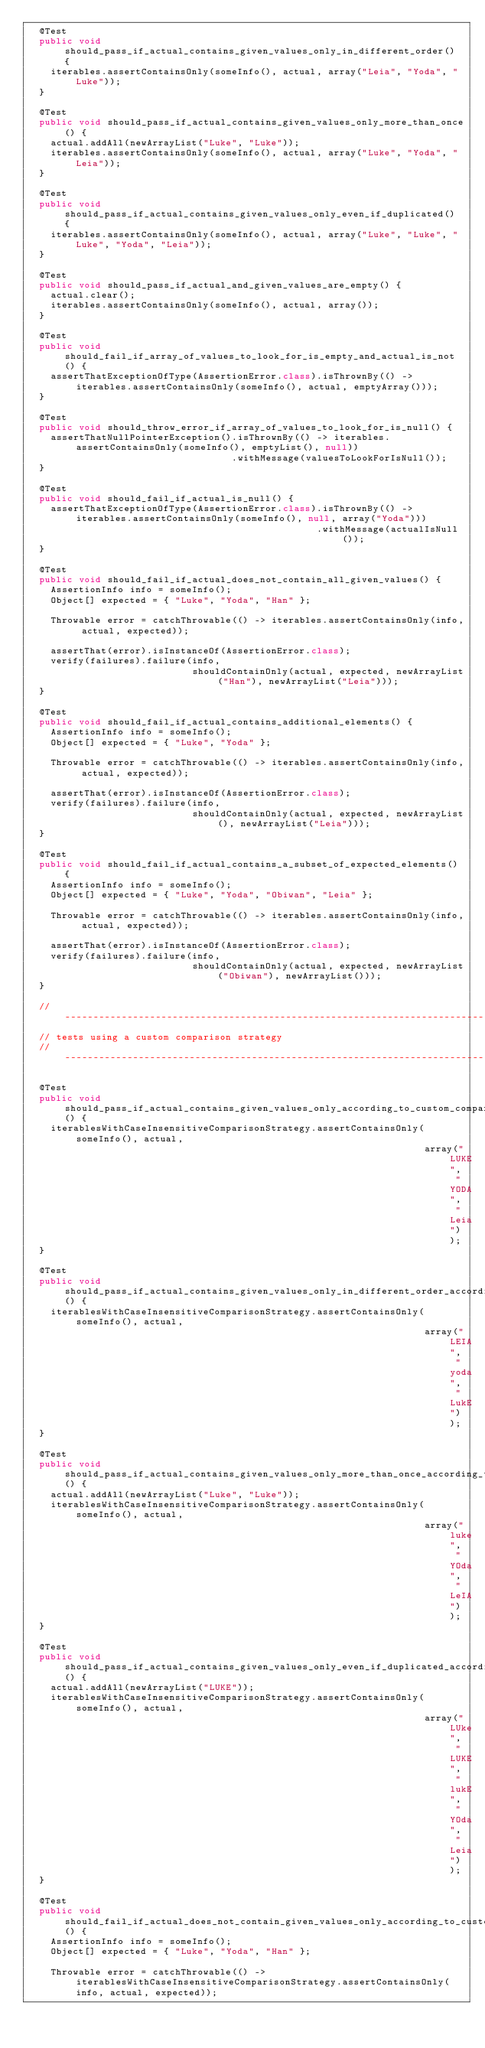<code> <loc_0><loc_0><loc_500><loc_500><_Java_>  @Test
  public void should_pass_if_actual_contains_given_values_only_in_different_order() {
    iterables.assertContainsOnly(someInfo(), actual, array("Leia", "Yoda", "Luke"));
  }

  @Test
  public void should_pass_if_actual_contains_given_values_only_more_than_once() {
    actual.addAll(newArrayList("Luke", "Luke"));
    iterables.assertContainsOnly(someInfo(), actual, array("Luke", "Yoda", "Leia"));
  }

  @Test
  public void should_pass_if_actual_contains_given_values_only_even_if_duplicated() {
    iterables.assertContainsOnly(someInfo(), actual, array("Luke", "Luke", "Luke", "Yoda", "Leia"));
  }

  @Test
  public void should_pass_if_actual_and_given_values_are_empty() {
    actual.clear();
    iterables.assertContainsOnly(someInfo(), actual, array());
  }

  @Test
  public void should_fail_if_array_of_values_to_look_for_is_empty_and_actual_is_not() {
    assertThatExceptionOfType(AssertionError.class).isThrownBy(() -> iterables.assertContainsOnly(someInfo(), actual, emptyArray()));
  }

  @Test
  public void should_throw_error_if_array_of_values_to_look_for_is_null() {
    assertThatNullPointerException().isThrownBy(() -> iterables.assertContainsOnly(someInfo(), emptyList(), null))
                                    .withMessage(valuesToLookForIsNull());
  }

  @Test
  public void should_fail_if_actual_is_null() {
    assertThatExceptionOfType(AssertionError.class).isThrownBy(() -> iterables.assertContainsOnly(someInfo(), null, array("Yoda")))
                                                   .withMessage(actualIsNull());
  }

  @Test
  public void should_fail_if_actual_does_not_contain_all_given_values() {
    AssertionInfo info = someInfo();
    Object[] expected = { "Luke", "Yoda", "Han" };

    Throwable error = catchThrowable(() -> iterables.assertContainsOnly(info, actual, expected));

    assertThat(error).isInstanceOf(AssertionError.class);
    verify(failures).failure(info,
                             shouldContainOnly(actual, expected, newArrayList("Han"), newArrayList("Leia")));
  }

  @Test
  public void should_fail_if_actual_contains_additional_elements() {
    AssertionInfo info = someInfo();
    Object[] expected = { "Luke", "Yoda" };

    Throwable error = catchThrowable(() -> iterables.assertContainsOnly(info, actual, expected));

    assertThat(error).isInstanceOf(AssertionError.class);
    verify(failures).failure(info,
                             shouldContainOnly(actual, expected, newArrayList(), newArrayList("Leia")));
  }

  @Test
  public void should_fail_if_actual_contains_a_subset_of_expected_elements() {
    AssertionInfo info = someInfo();
    Object[] expected = { "Luke", "Yoda", "Obiwan", "Leia" };

    Throwable error = catchThrowable(() -> iterables.assertContainsOnly(info, actual, expected));

    assertThat(error).isInstanceOf(AssertionError.class);
    verify(failures).failure(info,
                             shouldContainOnly(actual, expected, newArrayList("Obiwan"), newArrayList()));
  }

  // ------------------------------------------------------------------------------------------------------------------
  // tests using a custom comparison strategy
  // ------------------------------------------------------------------------------------------------------------------

  @Test
  public void should_pass_if_actual_contains_given_values_only_according_to_custom_comparison_strategy() {
    iterablesWithCaseInsensitiveComparisonStrategy.assertContainsOnly(someInfo(), actual,
                                                                      array("LUKE", "YODA", "Leia"));
  }

  @Test
  public void should_pass_if_actual_contains_given_values_only_in_different_order_according_to_custom_comparison_strategy() {
    iterablesWithCaseInsensitiveComparisonStrategy.assertContainsOnly(someInfo(), actual,
                                                                      array("LEIA", "yoda", "LukE"));
  }

  @Test
  public void should_pass_if_actual_contains_given_values_only_more_than_once_according_to_custom_comparison_strategy() {
    actual.addAll(newArrayList("Luke", "Luke"));
    iterablesWithCaseInsensitiveComparisonStrategy.assertContainsOnly(someInfo(), actual,
                                                                      array("luke", "YOda", "LeIA"));
  }

  @Test
  public void should_pass_if_actual_contains_given_values_only_even_if_duplicated_according_to_custom_comparison_strategy() {
    actual.addAll(newArrayList("LUKE"));
    iterablesWithCaseInsensitiveComparisonStrategy.assertContainsOnly(someInfo(), actual,
                                                                      array("LUke", "LUKE", "lukE", "YOda", "Leia"));
  }

  @Test
  public void should_fail_if_actual_does_not_contain_given_values_only_according_to_custom_comparison_strategy() {
    AssertionInfo info = someInfo();
    Object[] expected = { "Luke", "Yoda", "Han" };

    Throwable error = catchThrowable(() -> iterablesWithCaseInsensitiveComparisonStrategy.assertContainsOnly(info, actual, expected));
</code> 